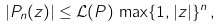<formula> <loc_0><loc_0><loc_500><loc_500>| P _ { n } ( z ) | \leq \mathcal { L } ( P ) \, \max \{ 1 , | z | \} ^ { n } \, ,</formula> 